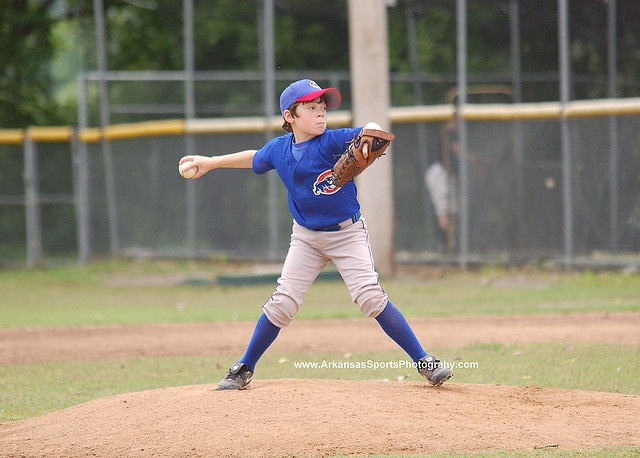Describe the objects in this image and their specific colors. I can see people in black, lightgray, tan, navy, and blue tones, baseball glove in black, brown, maroon, and gray tones, and sports ball in black, tan, and ivory tones in this image. 